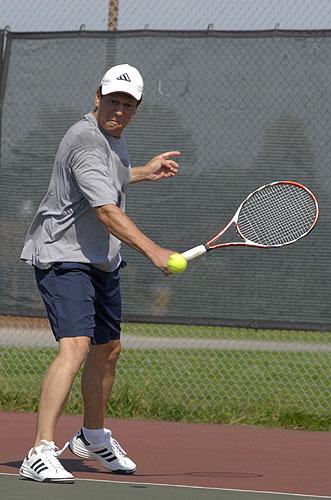Is this man sweating?
Give a very brief answer. Yes. How old is this person?
Be succinct. 40. Does the man have facial hair?
Be succinct. No. Are people watching the game?
Write a very short answer. No. Are they professionals?
Give a very brief answer. No. What is around the man's head?
Write a very short answer. Hat. What color are his clothes?
Quick response, please. Blue. Are any of the man's feet touching the ground?
Be succinct. Yes. What is this place?
Concise answer only. Tennis court. What is this person holding?
Quick response, please. Tennis racket. What color is the ball?
Give a very brief answer. Yellow. Is this an adult?
Give a very brief answer. Yes. What color of clothing is different than the other pieces?
Be succinct. Shorts. What color are his shoes?
Give a very brief answer. White. Is he wearing socks?
Concise answer only. Yes. What color is the man's shirt?
Write a very short answer. Gray. 